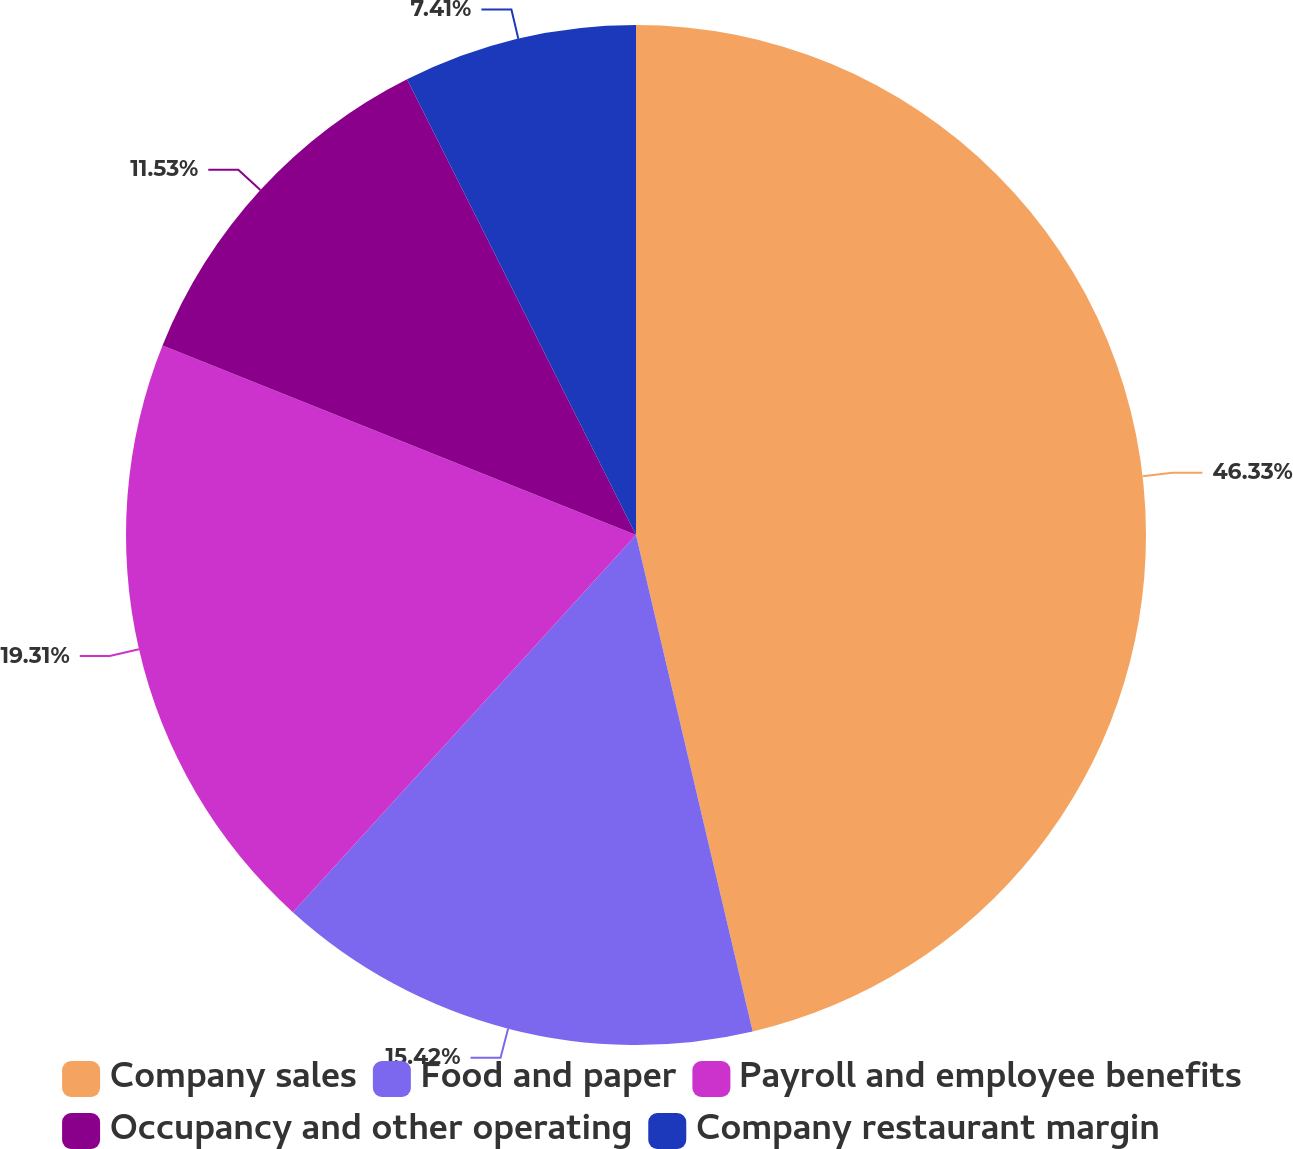Convert chart to OTSL. <chart><loc_0><loc_0><loc_500><loc_500><pie_chart><fcel>Company sales<fcel>Food and paper<fcel>Payroll and employee benefits<fcel>Occupancy and other operating<fcel>Company restaurant margin<nl><fcel>46.32%<fcel>15.42%<fcel>19.31%<fcel>11.53%<fcel>7.41%<nl></chart> 